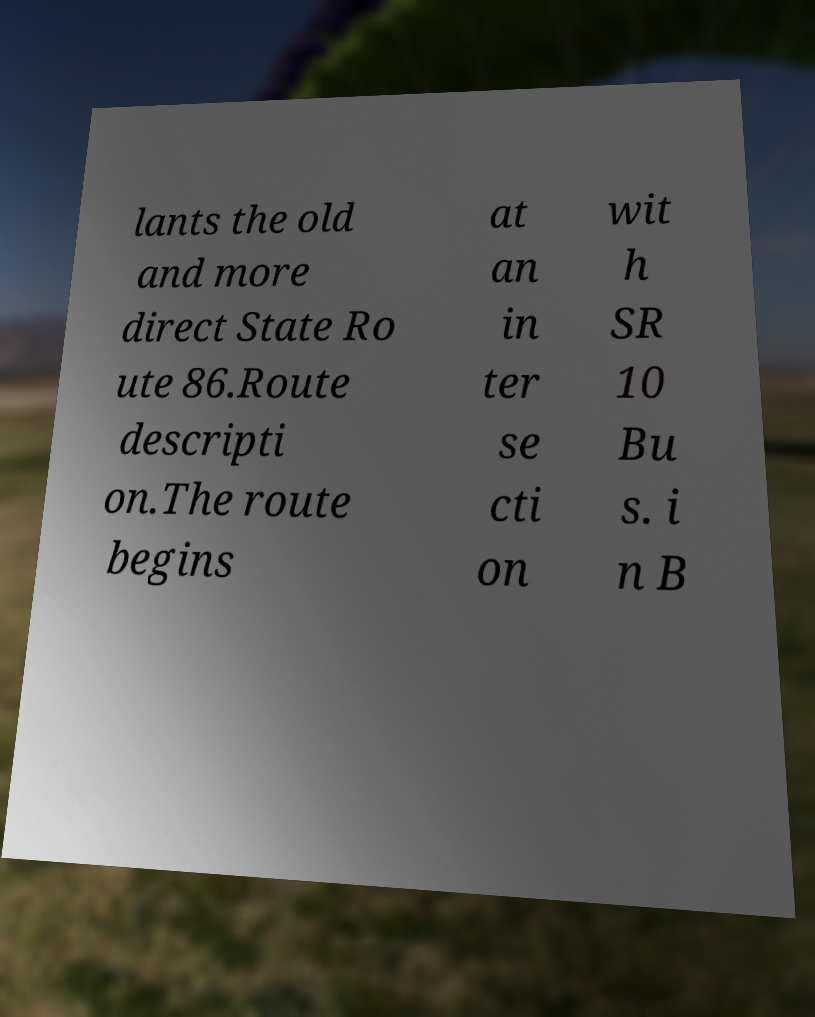Please read and relay the text visible in this image. What does it say? lants the old and more direct State Ro ute 86.Route descripti on.The route begins at an in ter se cti on wit h SR 10 Bu s. i n B 